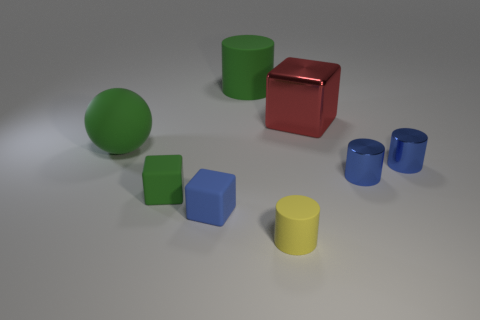What can you deduce about the relative sizes of the objects? From the perspective given, we can observe that the green sphere is the largest object, while other objects like the cubes and cylinders are significantly smaller. The red cube appears to be the second largest, followed by the blue cylinders and the yellow cylinder, with the blue cube being the smallest. 